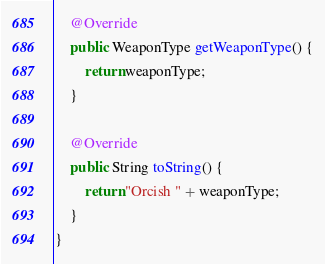Convert code to text. <code><loc_0><loc_0><loc_500><loc_500><_Java_>    @Override
    public WeaponType getWeaponType() {
        return weaponType;
    }

    @Override
    public String toString() {
        return "Orcish " + weaponType;
    }
}
</code> 